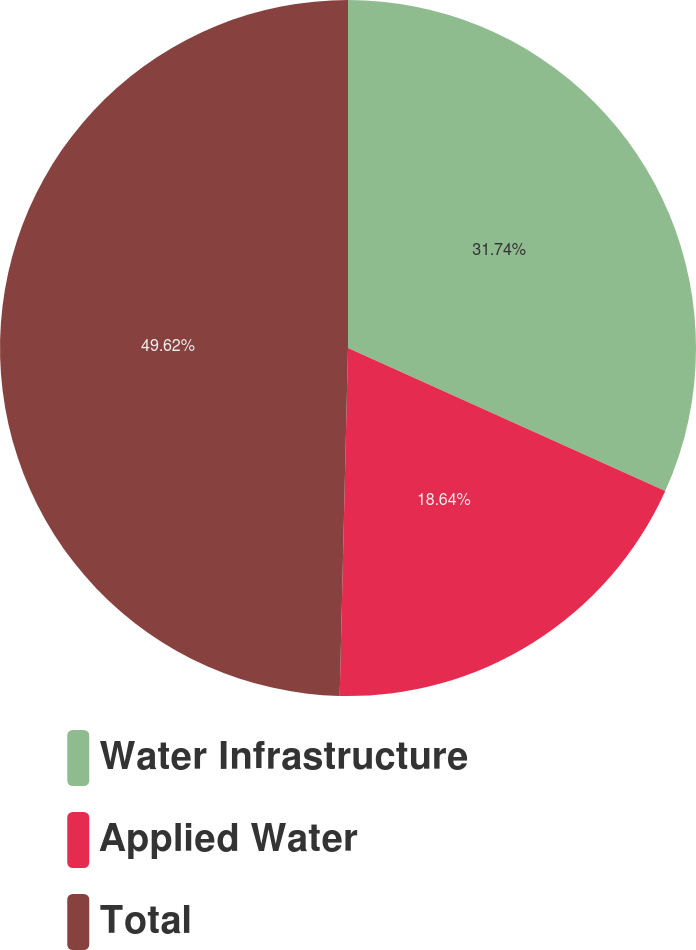<chart> <loc_0><loc_0><loc_500><loc_500><pie_chart><fcel>Water Infrastructure<fcel>Applied Water<fcel>Total<nl><fcel>31.74%<fcel>18.64%<fcel>49.62%<nl></chart> 